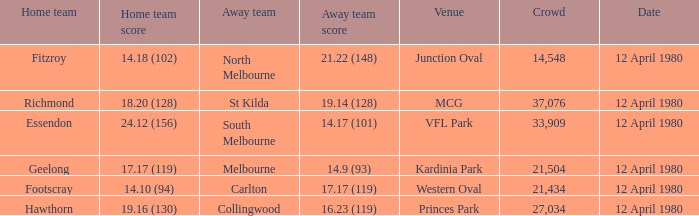Where did fitzroy play as the home team? Junction Oval. 